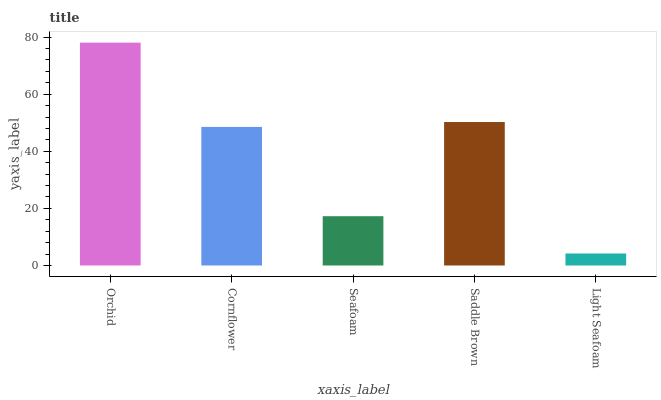Is Cornflower the minimum?
Answer yes or no. No. Is Cornflower the maximum?
Answer yes or no. No. Is Orchid greater than Cornflower?
Answer yes or no. Yes. Is Cornflower less than Orchid?
Answer yes or no. Yes. Is Cornflower greater than Orchid?
Answer yes or no. No. Is Orchid less than Cornflower?
Answer yes or no. No. Is Cornflower the high median?
Answer yes or no. Yes. Is Cornflower the low median?
Answer yes or no. Yes. Is Orchid the high median?
Answer yes or no. No. Is Seafoam the low median?
Answer yes or no. No. 